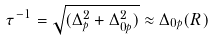<formula> <loc_0><loc_0><loc_500><loc_500>\tau ^ { - 1 } = \sqrt { ( \Delta _ { p } ^ { 2 } + \Delta _ { 0 p } ^ { 2 } ) } \approx \Delta _ { 0 p } ( R )</formula> 